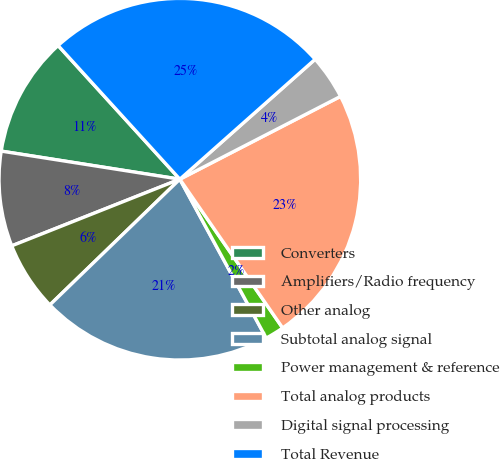Convert chart. <chart><loc_0><loc_0><loc_500><loc_500><pie_chart><fcel>Converters<fcel>Amplifiers/Radio frequency<fcel>Other analog<fcel>Subtotal analog signal<fcel>Power management & reference<fcel>Total analog products<fcel>Digital signal processing<fcel>Total Revenue<nl><fcel>10.76%<fcel>8.49%<fcel>6.23%<fcel>20.69%<fcel>1.7%<fcel>22.95%<fcel>3.97%<fcel>25.21%<nl></chart> 